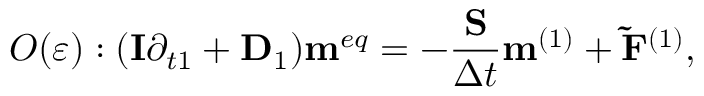<formula> <loc_0><loc_0><loc_500><loc_500>O ( \varepsilon ) \colon ( { I } { \partial _ { t 1 } } + { { D } _ { 1 } } ) { { m } ^ { e q } } = - \frac { S } { \Delta t } { { m } ^ { ( 1 ) } } + { { \tilde { F } } ^ { ( 1 ) } } ,</formula> 